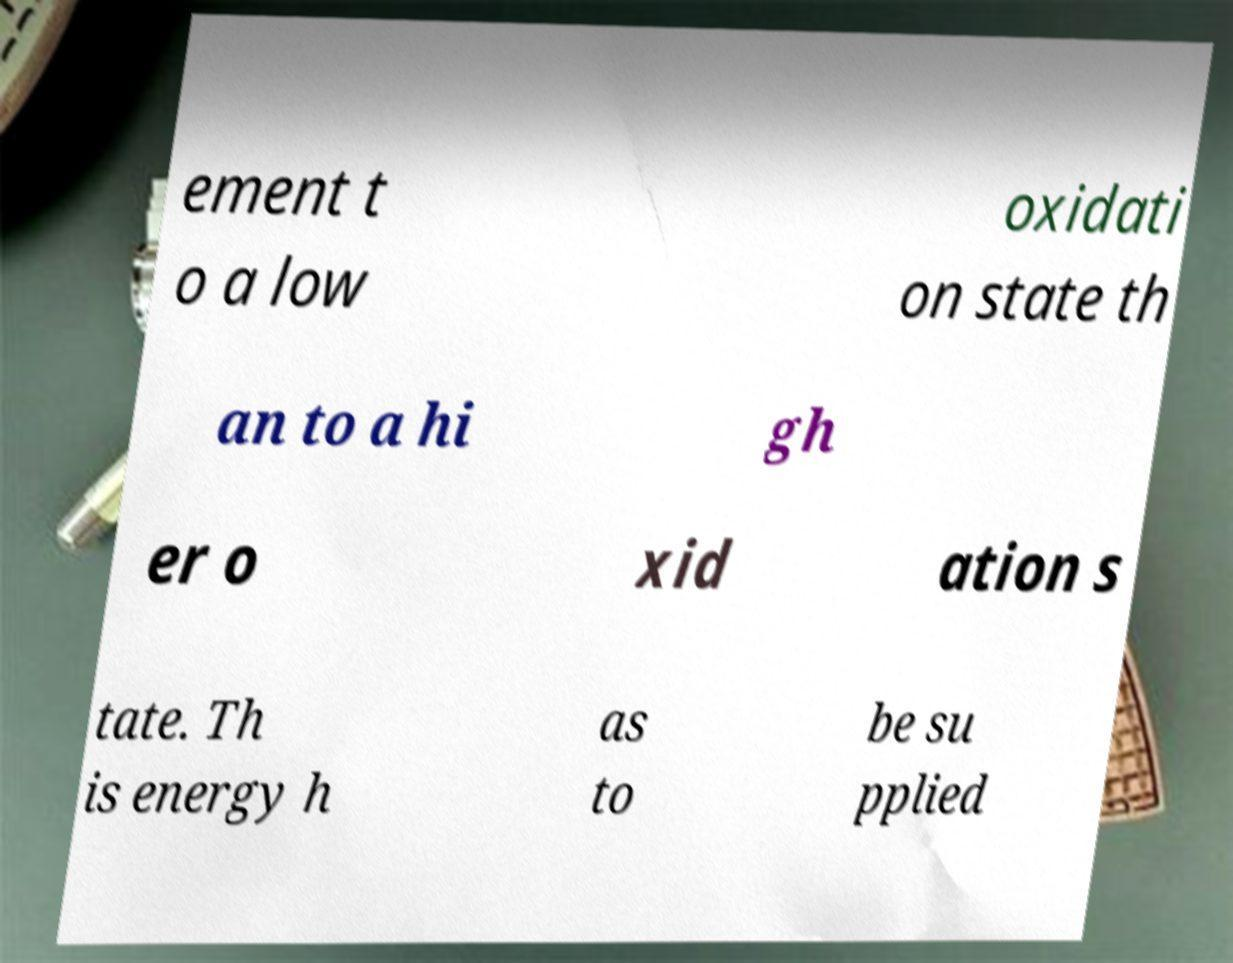Can you read and provide the text displayed in the image?This photo seems to have some interesting text. Can you extract and type it out for me? ement t o a low oxidati on state th an to a hi gh er o xid ation s tate. Th is energy h as to be su pplied 